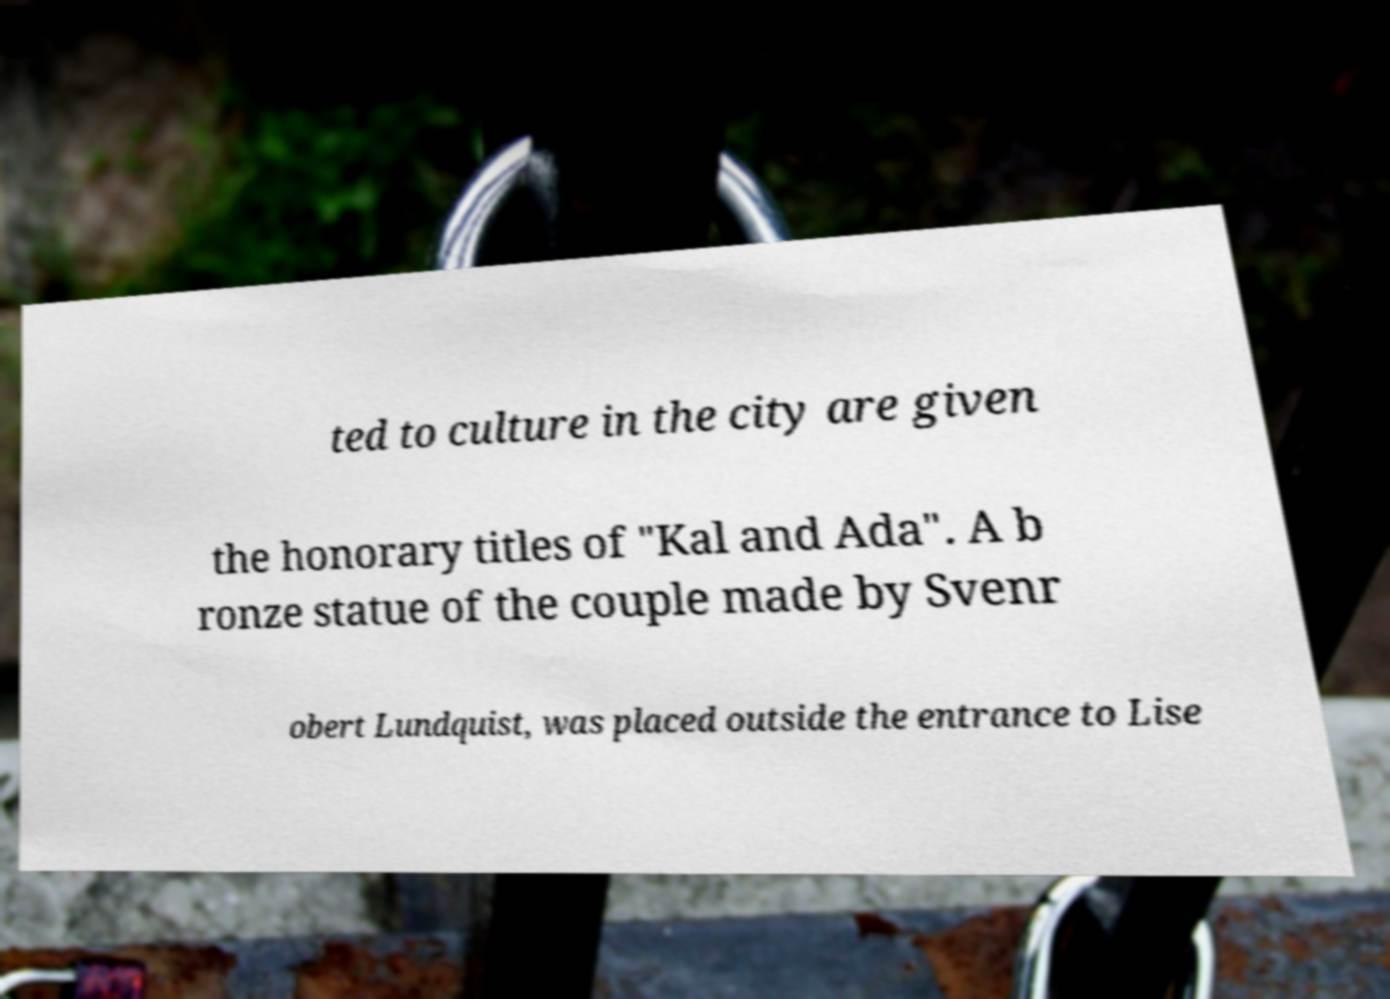I need the written content from this picture converted into text. Can you do that? ted to culture in the city are given the honorary titles of "Kal and Ada". A b ronze statue of the couple made by Svenr obert Lundquist, was placed outside the entrance to Lise 